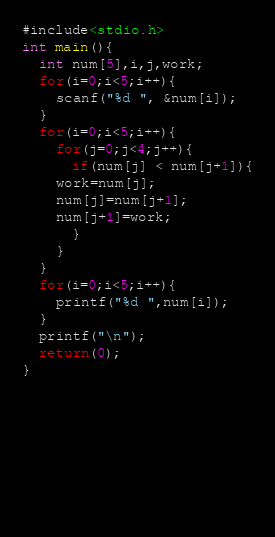<code> <loc_0><loc_0><loc_500><loc_500><_C_>#include<stdio.h>
int main(){
  int num[5],i,j,work;
  for(i=0;i<5;i++){
    scanf("%d ", &num[i]);
  }
  for(i=0;i<5;i++){
    for(j=0;j<4;j++){
      if(num[j] < num[j+1]){
	work=num[j];
	num[j]=num[j+1];
	num[j+1]=work;
      }
    }
  }
  for(i=0;i<5;i++){
    printf("%d ",num[i]);
  }
  printf("\n");
  return(0);
}  


  


                       

                        </code> 